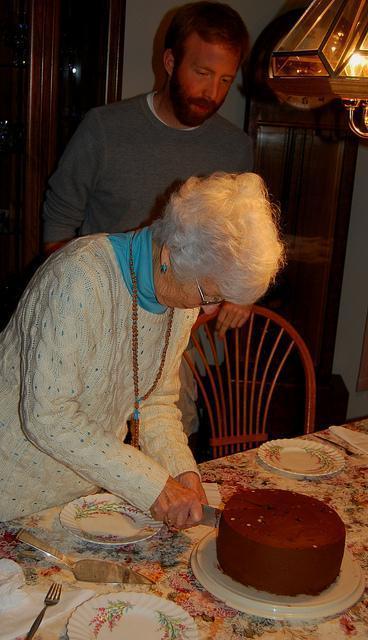How many people are in the picture?
Give a very brief answer. 2. How many cars are parked on the right side of the road?
Give a very brief answer. 0. 